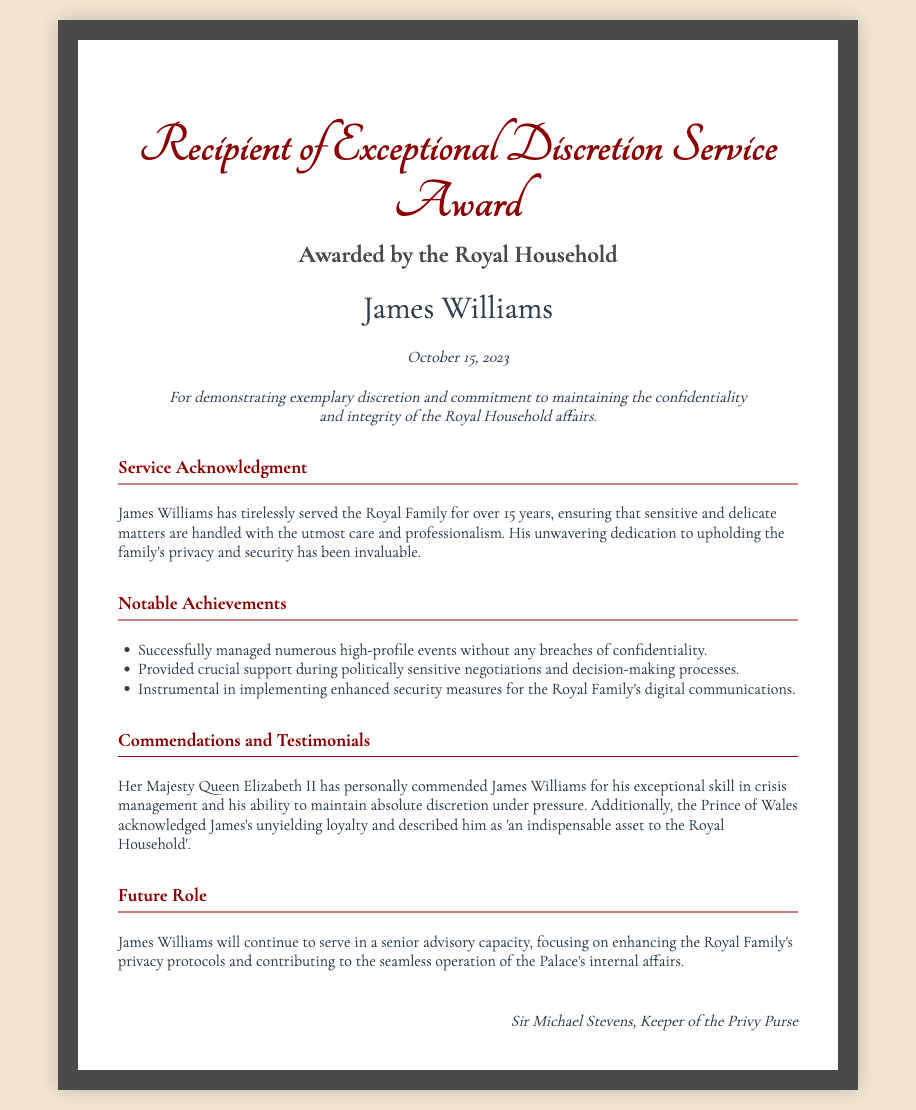What is the recipient's name? The recipient's name is mentioned prominently in the document.
Answer: James Williams When was the award presented? The date of the award is stated in the document.
Answer: October 15, 2023 Who awarded this certificate? The awarding authority is specified in the document's header.
Answer: Royal Household What is the citation for the award? The citation outlines the reason for the award.
Answer: For demonstrating exemplary discretion and commitment to maintaining the confidentiality and integrity of the Royal Household affairs How many years has James Williams served the Royal Family? The document provides the length of service in years.
Answer: over 15 years Which royal figure commended James Williams? The document mentions a specific royal figure who praised the recipient.
Answer: Her Majesty Queen Elizabeth II What is James's upcoming role? The document mentions the future responsibilities of James Williams.
Answer: senior advisory capacity What notable achievement involves managing events? The document lists achievements, including a specific focus on events.
Answer: Successfully managed numerous high-profile events without any breaches of confidentiality What is the signature authority on the certificate? The signature at the bottom indicates the authority behind the award.
Answer: Sir Michael Stevens, Keeper of the Privy Purse 